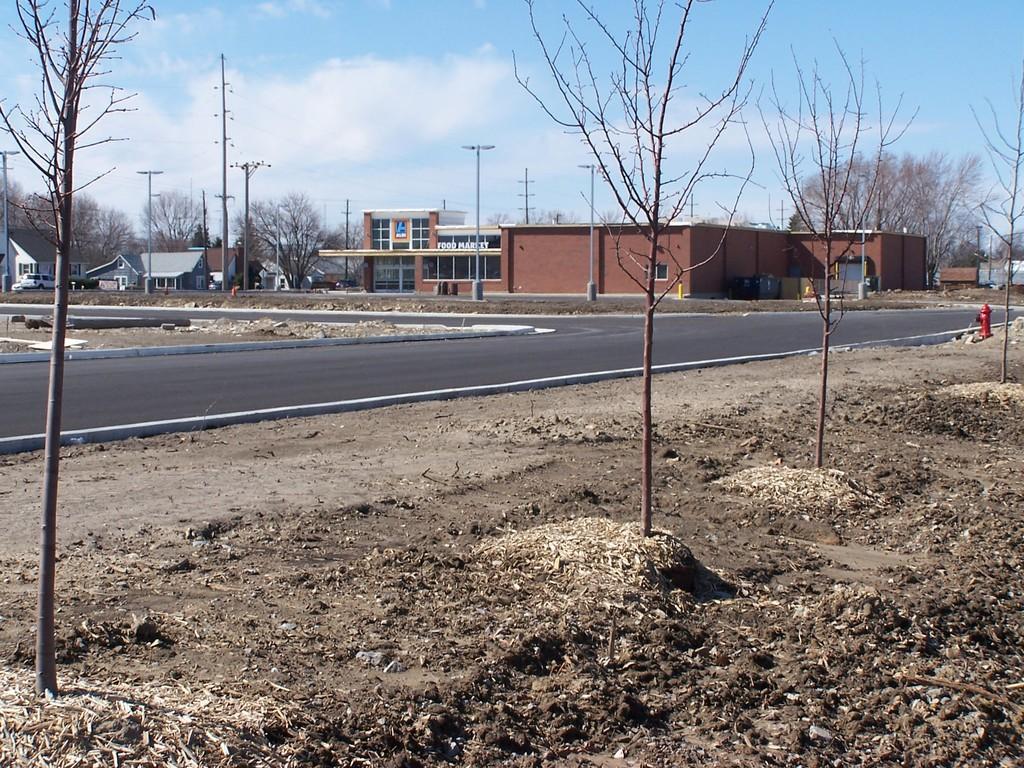Could you give a brief overview of what you see in this image? In this picture we can see trees on the ground, road, hydrant, buildings, poles, some objects and in the background we can see the sky. 